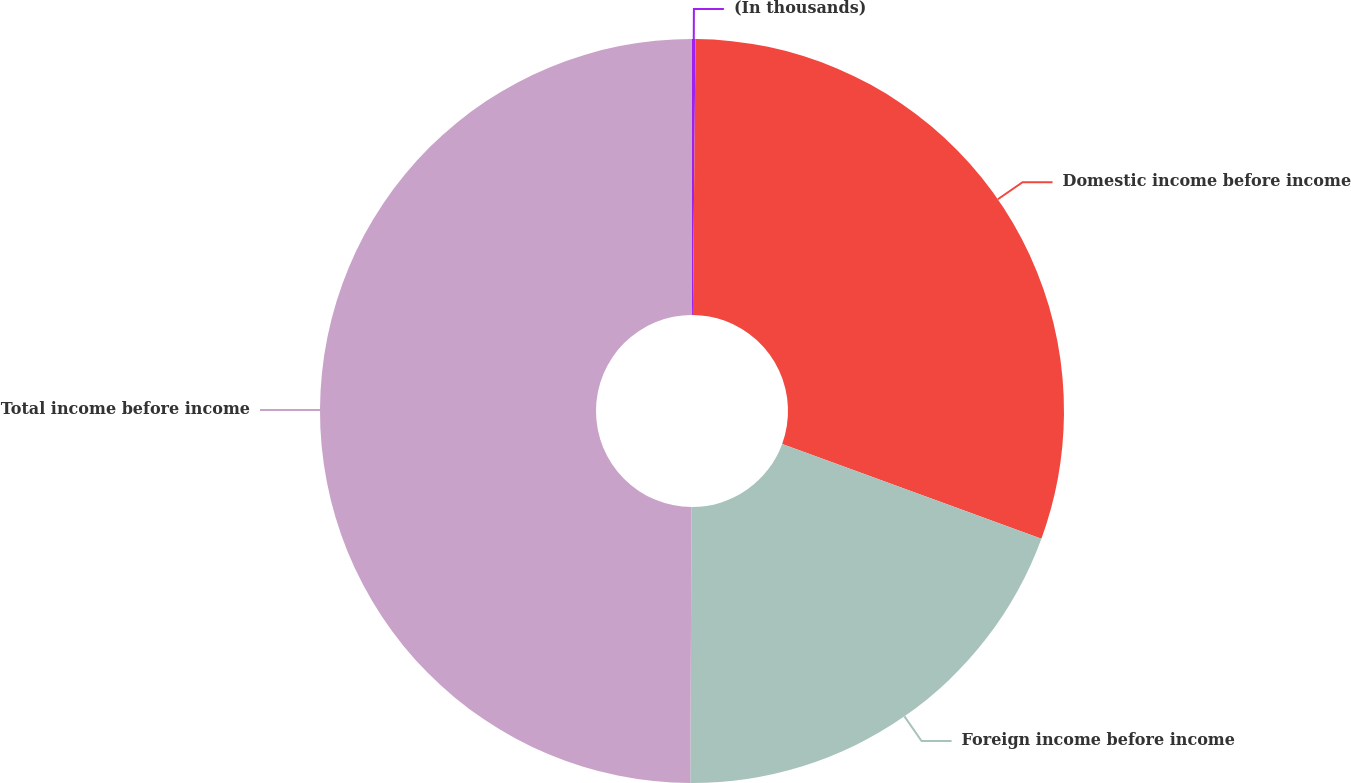Convert chart to OTSL. <chart><loc_0><loc_0><loc_500><loc_500><pie_chart><fcel>(In thousands)<fcel>Domestic income before income<fcel>Foreign income before income<fcel>Total income before income<nl><fcel>0.15%<fcel>30.43%<fcel>19.5%<fcel>49.93%<nl></chart> 